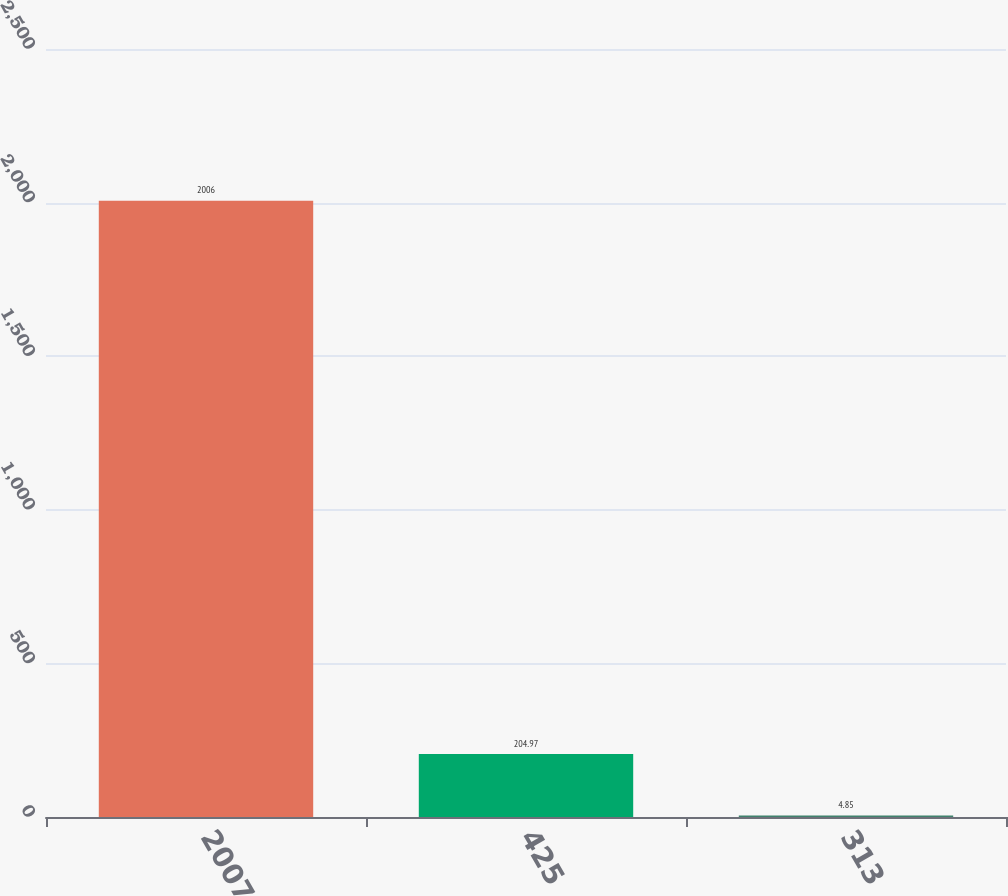Convert chart. <chart><loc_0><loc_0><loc_500><loc_500><bar_chart><fcel>2007<fcel>425<fcel>313<nl><fcel>2006<fcel>204.97<fcel>4.85<nl></chart> 